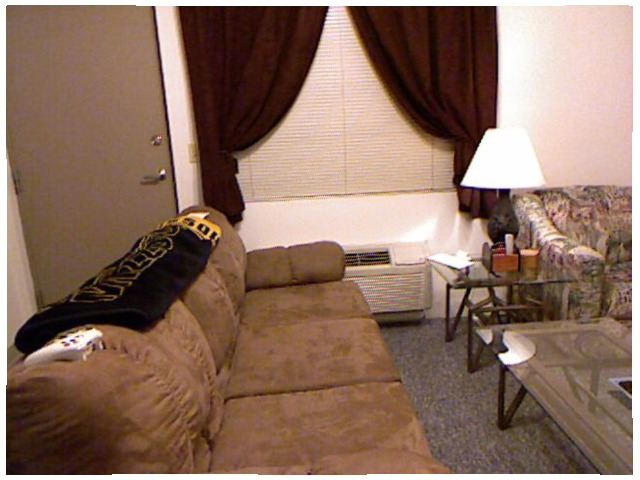<image>
Can you confirm if the air conditioner is under the curtain? Yes. The air conditioner is positioned underneath the curtain, with the curtain above it in the vertical space. Where is the lamp in relation to the coffee table? Is it on the coffee table? No. The lamp is not positioned on the coffee table. They may be near each other, but the lamp is not supported by or resting on top of the coffee table. Is the door behind the couch? Yes. From this viewpoint, the door is positioned behind the couch, with the couch partially or fully occluding the door. Is there a lamp to the right of the couch? No. The lamp is not to the right of the couch. The horizontal positioning shows a different relationship. Where is the lamp in relation to the sofa? Is it in the sofa? No. The lamp is not contained within the sofa. These objects have a different spatial relationship. Is the blanket next to the controller? Yes. The blanket is positioned adjacent to the controller, located nearby in the same general area. 